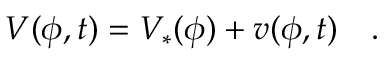<formula> <loc_0><loc_0><loc_500><loc_500>V ( \phi , t ) = V _ { * } ( \phi ) + v ( \phi , t ) \quad .</formula> 